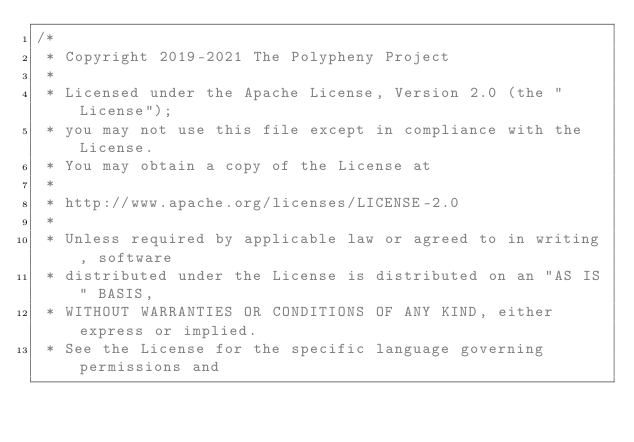<code> <loc_0><loc_0><loc_500><loc_500><_Java_>/*
 * Copyright 2019-2021 The Polypheny Project
 *
 * Licensed under the Apache License, Version 2.0 (the "License");
 * you may not use this file except in compliance with the License.
 * You may obtain a copy of the License at
 *
 * http://www.apache.org/licenses/LICENSE-2.0
 *
 * Unless required by applicable law or agreed to in writing, software
 * distributed under the License is distributed on an "AS IS" BASIS,
 * WITHOUT WARRANTIES OR CONDITIONS OF ANY KIND, either express or implied.
 * See the License for the specific language governing permissions and</code> 